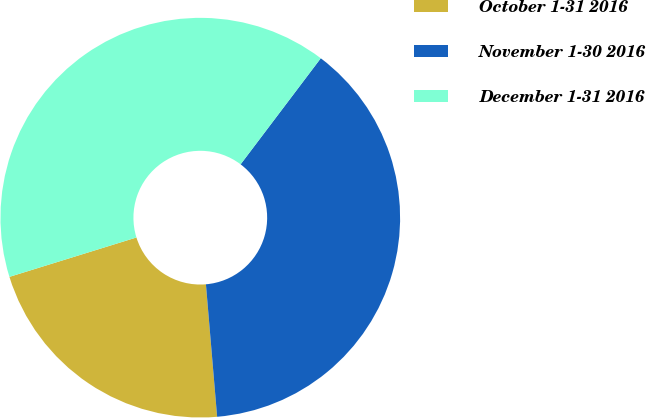<chart> <loc_0><loc_0><loc_500><loc_500><pie_chart><fcel>October 1-31 2016<fcel>November 1-30 2016<fcel>December 1-31 2016<nl><fcel>21.56%<fcel>38.36%<fcel>40.09%<nl></chart> 